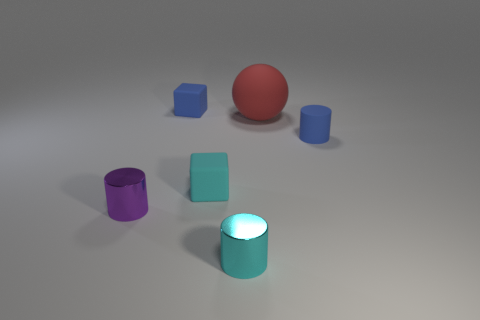Add 4 small blocks. How many objects exist? 10 Subtract all spheres. How many objects are left? 5 Add 6 large things. How many large things are left? 7 Add 5 purple cylinders. How many purple cylinders exist? 6 Subtract 0 purple balls. How many objects are left? 6 Subtract all purple objects. Subtract all tiny purple metal cubes. How many objects are left? 5 